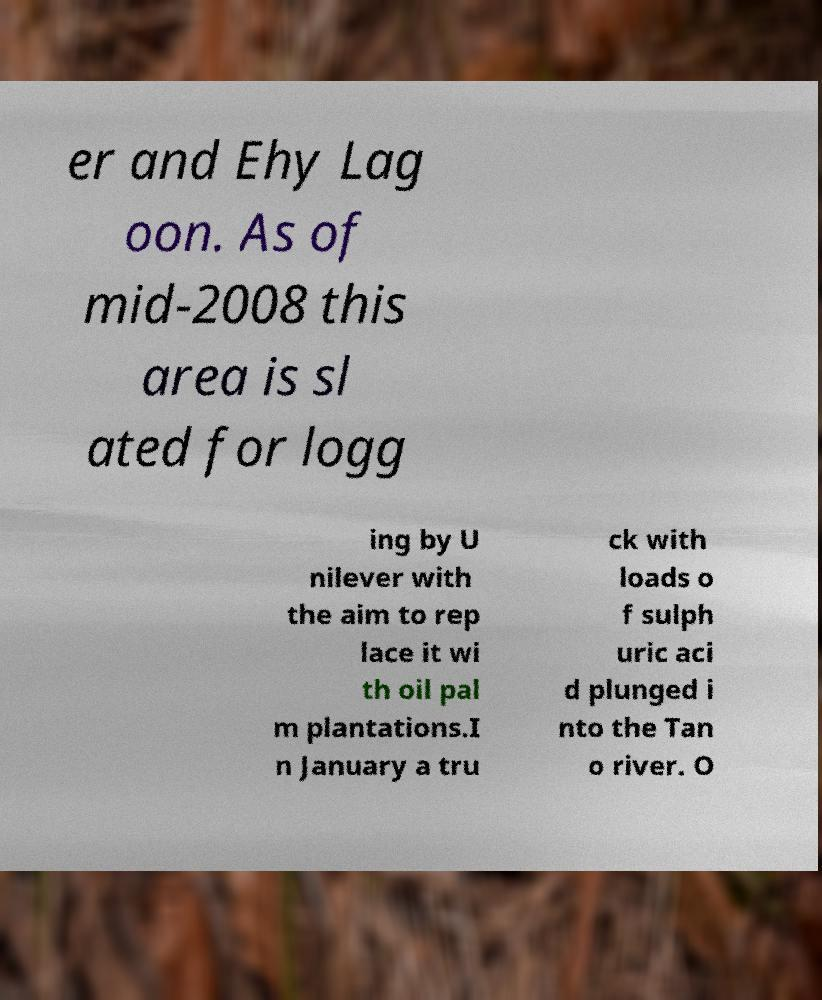Could you extract and type out the text from this image? er and Ehy Lag oon. As of mid-2008 this area is sl ated for logg ing by U nilever with the aim to rep lace it wi th oil pal m plantations.I n January a tru ck with loads o f sulph uric aci d plunged i nto the Tan o river. O 